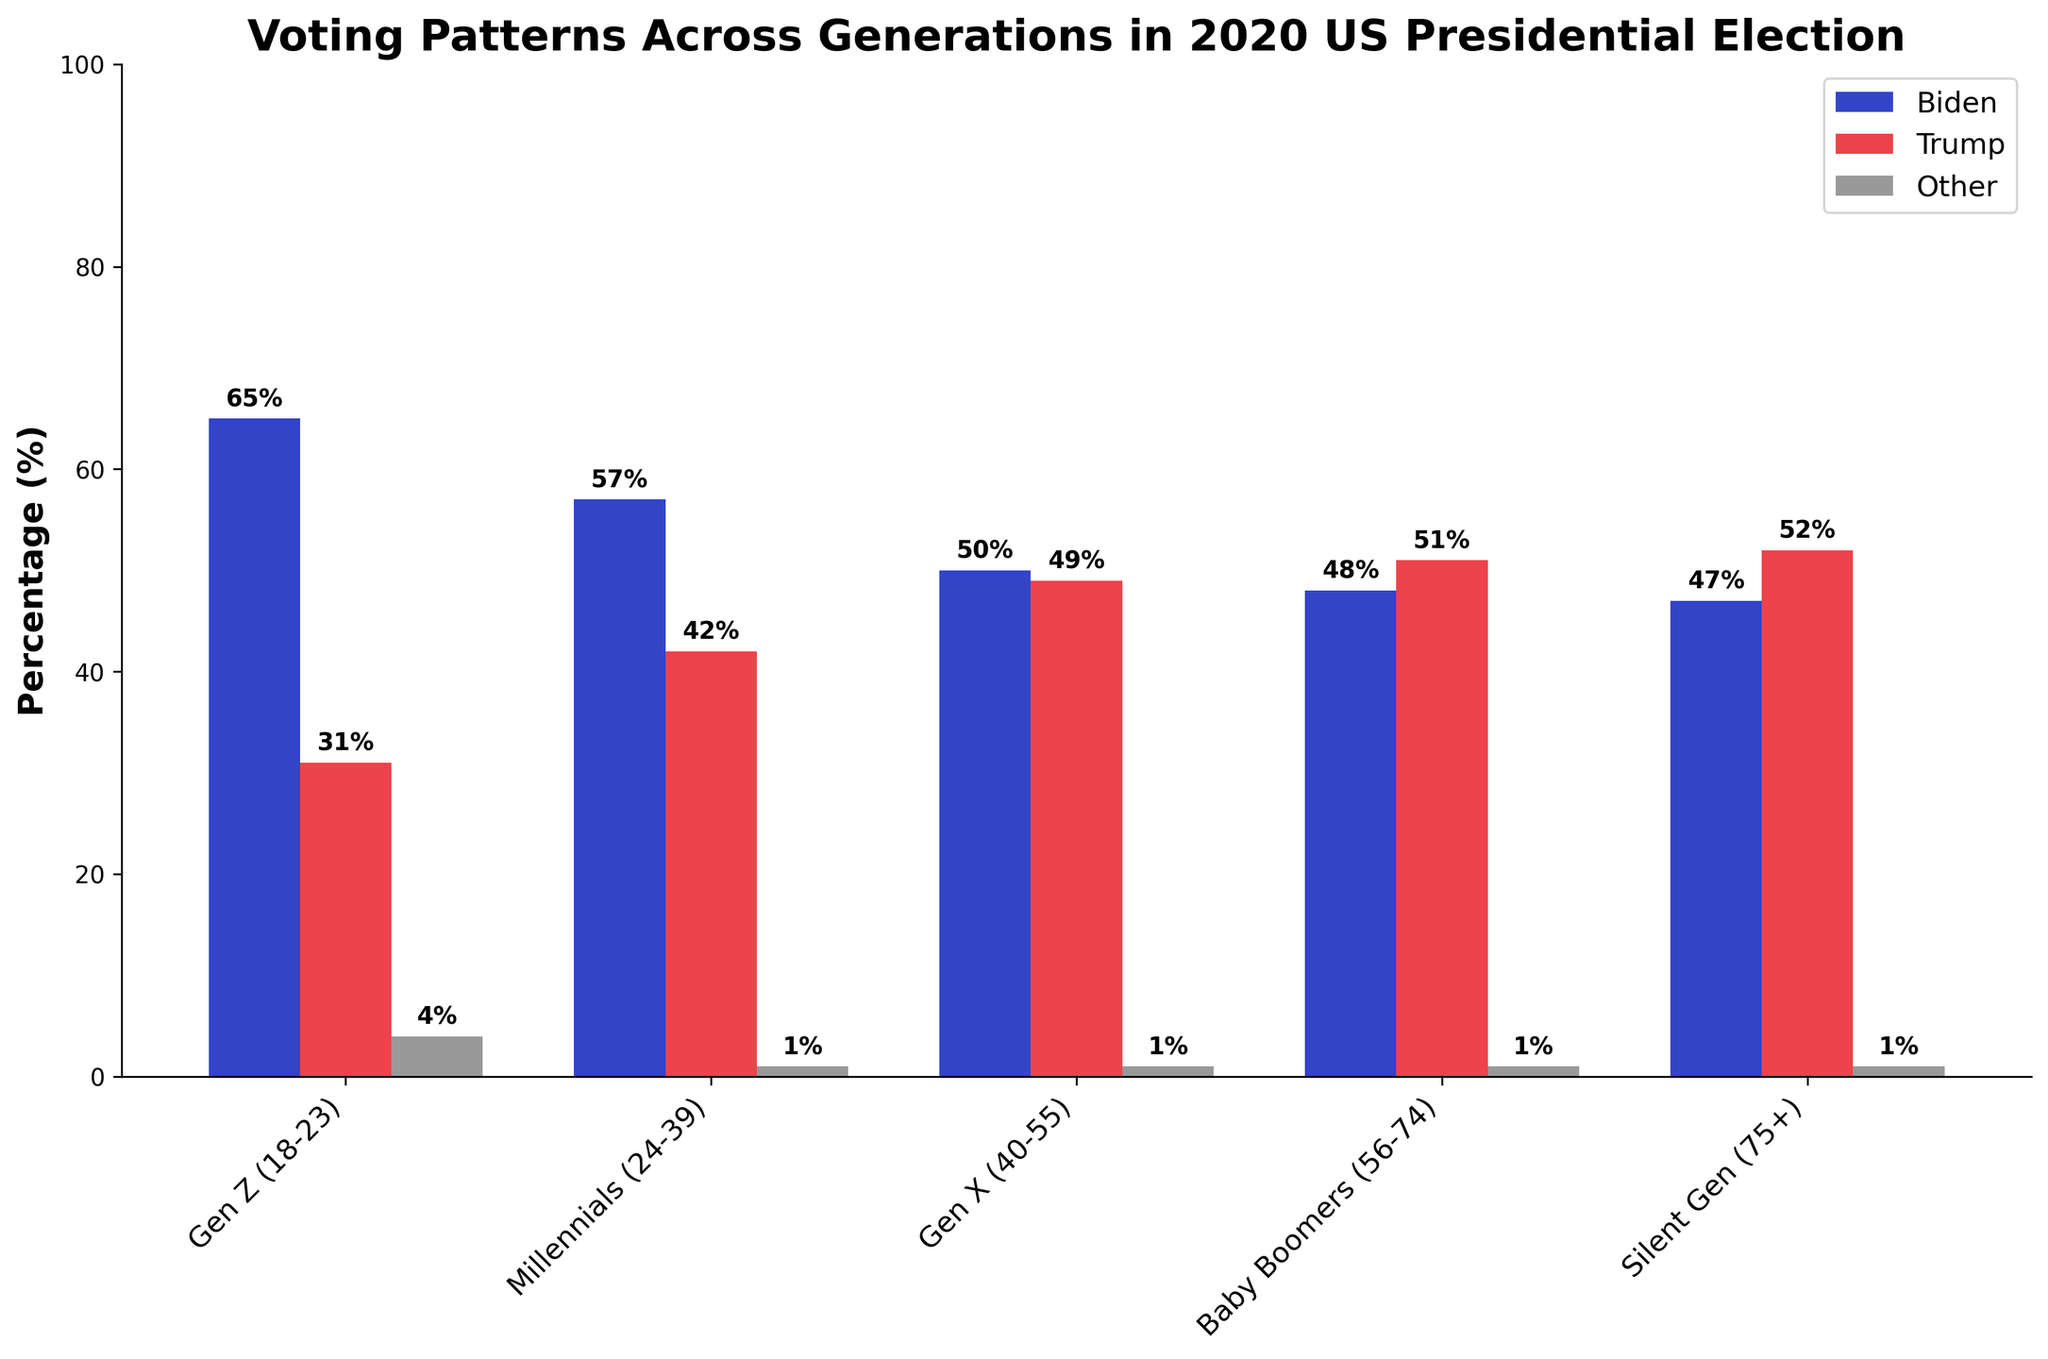What percentage of Millennials voted for Biden? According to the figure, the percentage of Millennials who voted for Biden is represented by the height of the blue bar labeled 'Millennials'.
Answer: 57% Which generation had the highest percentage of votes for Trump? To find the generation with the highest percentage of votes for Trump, look for the tallest red bar across the generations. The red bar is highest for 'Silent Gen'.
Answer: Silent Gen What is the combined percentage of Gen Z votes for 'Biden' and 'Other'? The percentage of votes for Biden is 65% and Other is 4% for Gen Z. Combining these values, 65% + 4% = 69%.
Answer: 69% Which generation had the smallest percentage difference between Biden and Trump votes? To find the smallest difference, calculate the absolute difference between Biden and Trump votes for each generation. The smallest difference is for Gen X, with 1% (50% Biden - 49% Trump).
Answer: Gen X Out of Baby Boomers and Millennials, which generation had a higher percentage of 'Other' votes? By visually comparing the height of the gray bars for Baby Boomers and Millennials, we see that both generations had the same percentage of 'Other' votes, which is 1%.
Answer: Equal What is the total percentage of voters who supported candidates other than Biden or Trump across all generations? Sum the 'Other (%)' values for all generations: 4% (Gen Z) + 1% (Millennials) + 1% (Gen X) + 1% (Baby Boomers) + 1% (Silent Gen) = 8%.
Answer: 8% Compare the percentage of Baby Boomers who voted for Biden with Millennials who voted for Trump. Which was higher? The percentage of Baby Boomers who voted for Biden is 48%, whereas the percentage of Millennials who voted for Trump is 42%. 48% is higher than 42%.
Answer: Baby Boomers for Biden 